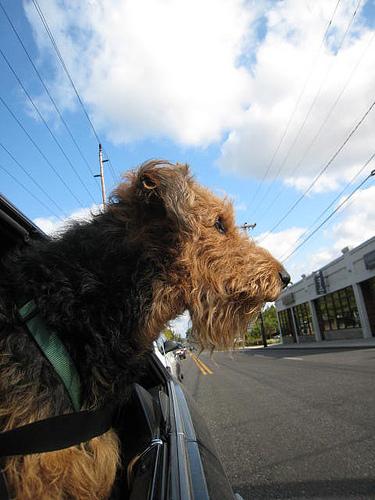Is the dog asleep?
Keep it brief. No. What is the dog riding in?
Quick response, please. Car. Is the dog wearing a seat belt?
Quick response, please. Yes. 